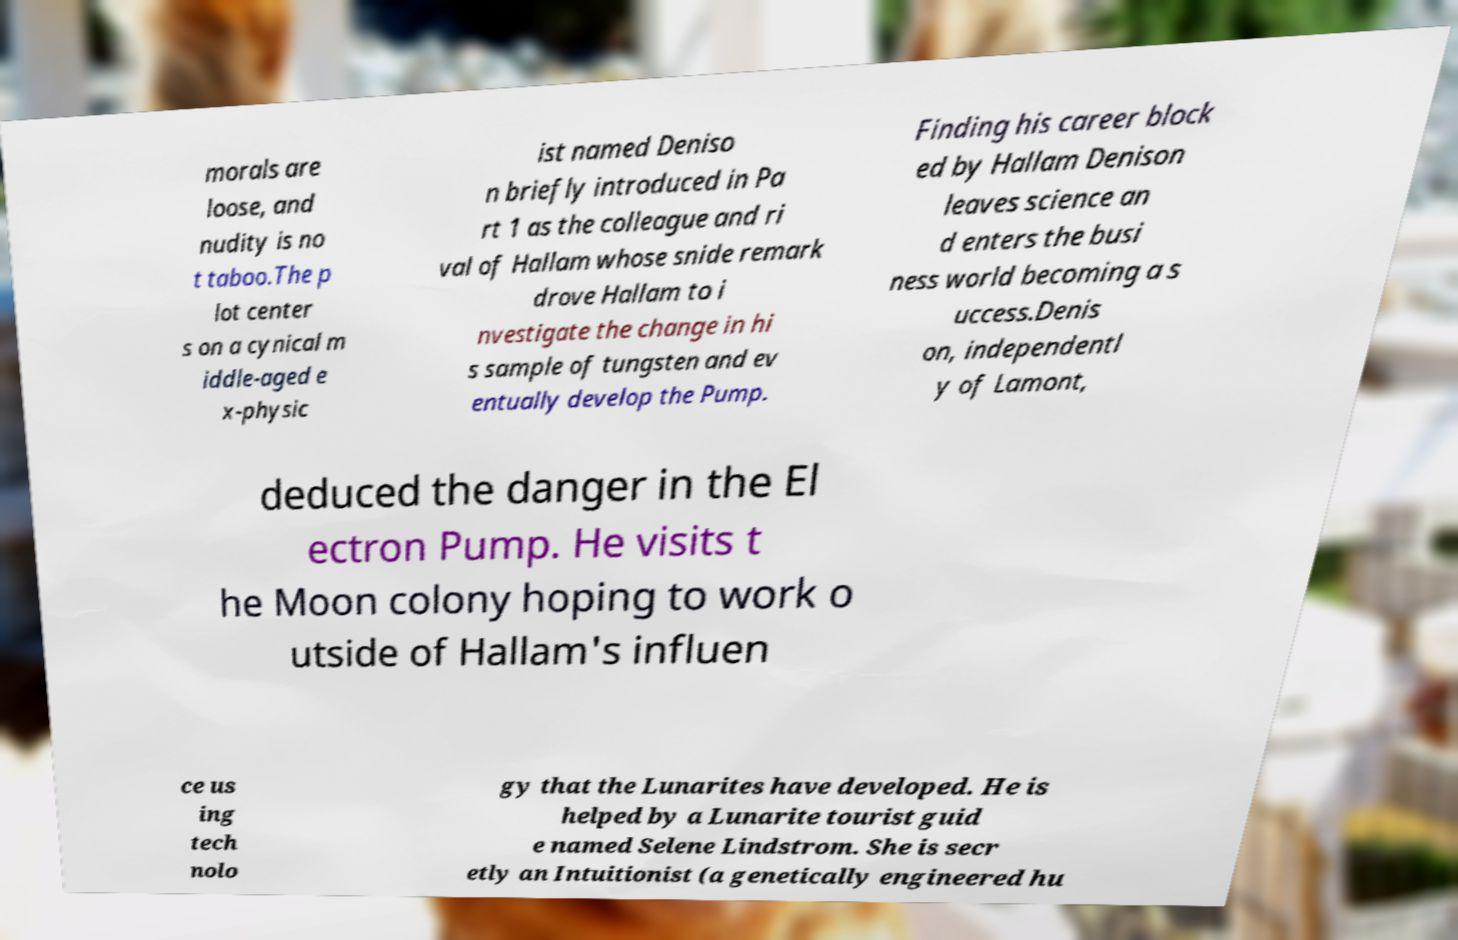Please read and relay the text visible in this image. What does it say? morals are loose, and nudity is no t taboo.The p lot center s on a cynical m iddle-aged e x-physic ist named Deniso n briefly introduced in Pa rt 1 as the colleague and ri val of Hallam whose snide remark drove Hallam to i nvestigate the change in hi s sample of tungsten and ev entually develop the Pump. Finding his career block ed by Hallam Denison leaves science an d enters the busi ness world becoming a s uccess.Denis on, independentl y of Lamont, deduced the danger in the El ectron Pump. He visits t he Moon colony hoping to work o utside of Hallam's influen ce us ing tech nolo gy that the Lunarites have developed. He is helped by a Lunarite tourist guid e named Selene Lindstrom. She is secr etly an Intuitionist (a genetically engineered hu 